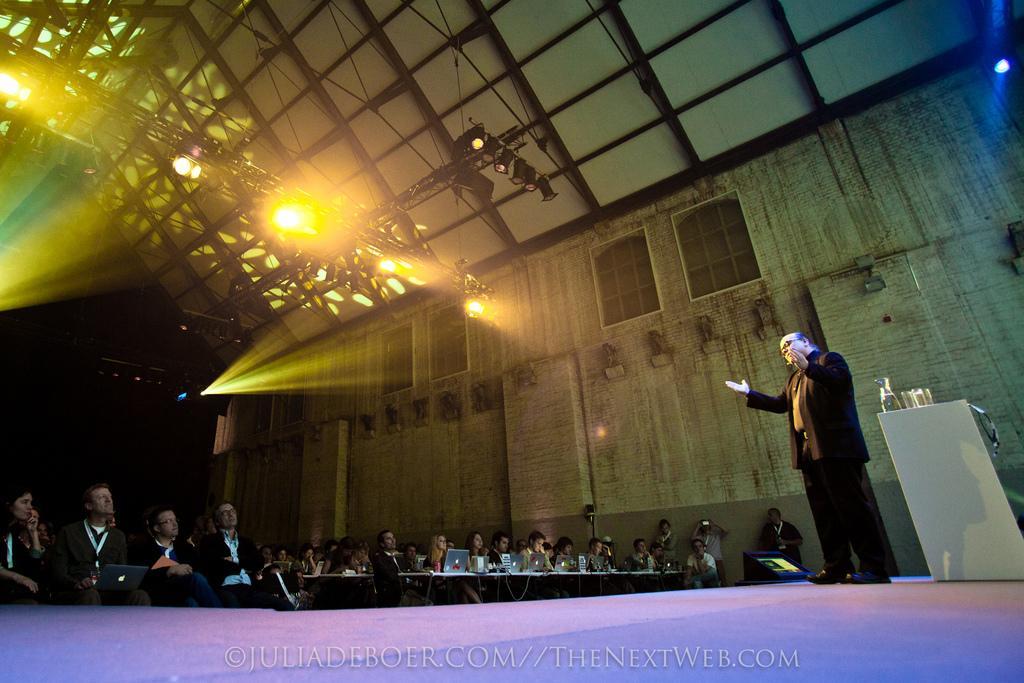Could you give a brief overview of what you see in this image? In this image there is a man standing on the stage and speaking in a microphone, in front of him there are so many people sitting on chairs and operating laptops. Also there are so many lights at the roof. 